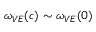<formula> <loc_0><loc_0><loc_500><loc_500>\omega _ { V E } ( c ) \sim \omega _ { V E } ( 0 )</formula> 